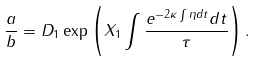<formula> <loc_0><loc_0><loc_500><loc_500>\frac { a } { b } = D _ { 1 } \exp \left ( X _ { 1 } \int \frac { e ^ { - 2 \kappa \int \eta d t } d t } { \tau } \right ) .</formula> 